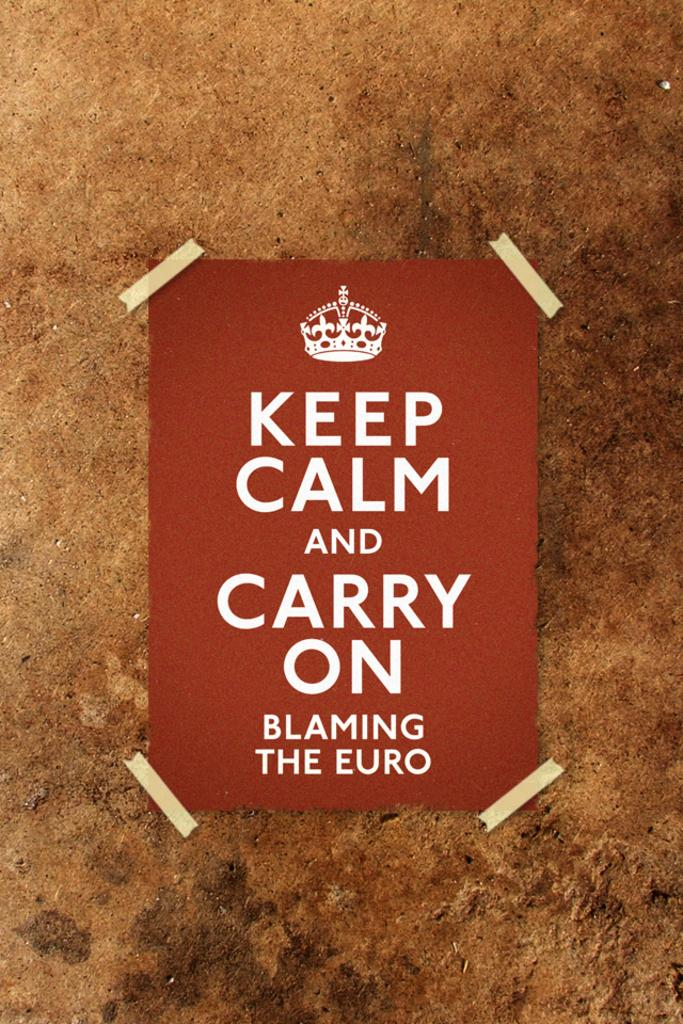Provide a one-sentence caption for the provided image. a poster reading keep calm and carry on. 